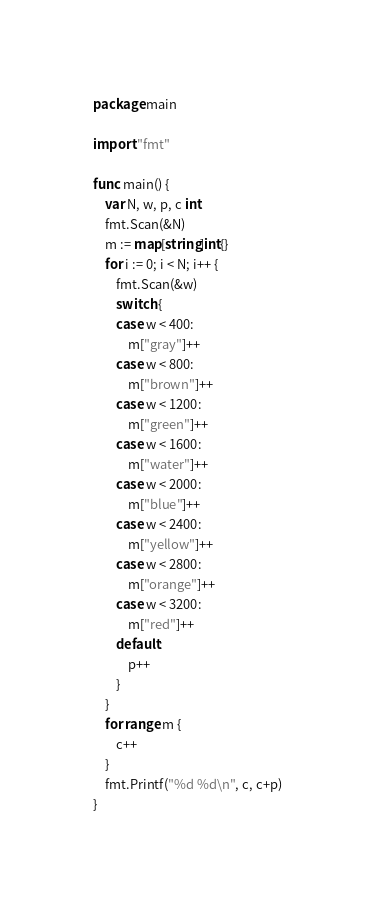<code> <loc_0><loc_0><loc_500><loc_500><_Go_>package main

import "fmt"

func main() {
	var N, w, p, c int
	fmt.Scan(&N)
	m := map[string]int{}
	for i := 0; i < N; i++ {
		fmt.Scan(&w)
		switch {
		case w < 400:
			m["gray"]++
		case w < 800:
			m["brown"]++
		case w < 1200:
			m["green"]++
		case w < 1600:
			m["water"]++
		case w < 2000:
			m["blue"]++
		case w < 2400:
			m["yellow"]++
		case w < 2800:
			m["orange"]++
		case w < 3200:
			m["red"]++
		default:
			p++
		}
	}
	for range m {
		c++
	}
	fmt.Printf("%d %d\n", c, c+p)
}</code> 